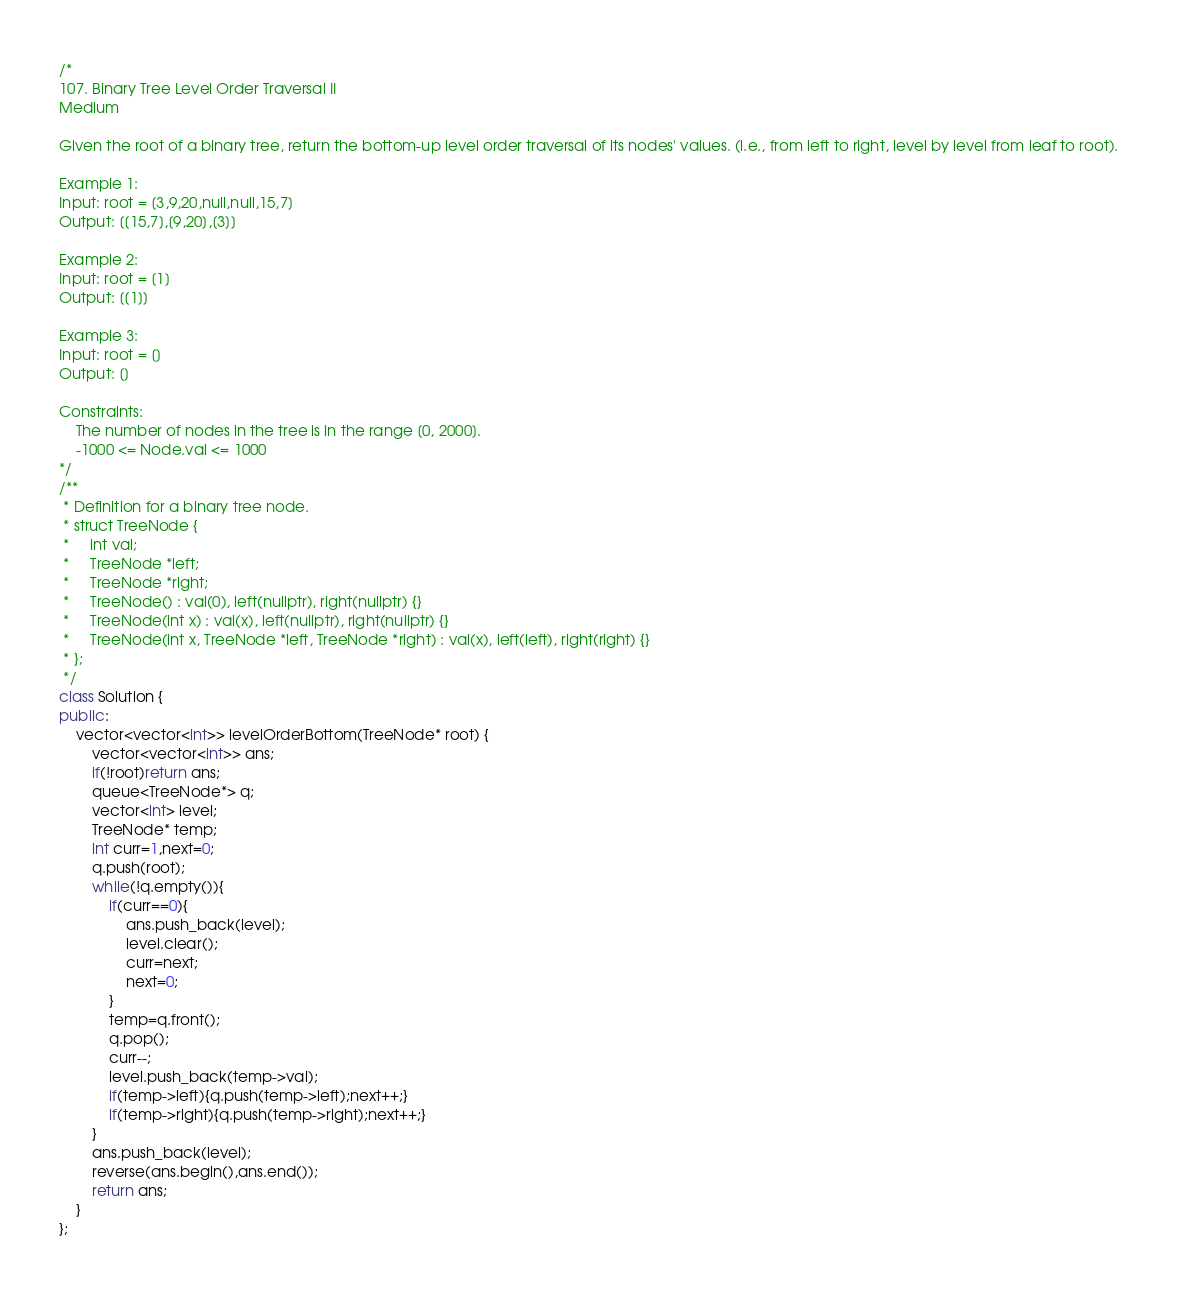Convert code to text. <code><loc_0><loc_0><loc_500><loc_500><_C++_>/*
107. Binary Tree Level Order Traversal II
Medium

Given the root of a binary tree, return the bottom-up level order traversal of its nodes' values. (i.e., from left to right, level by level from leaf to root).

Example 1:
Input: root = [3,9,20,null,null,15,7]
Output: [[15,7],[9,20],[3]]

Example 2:
Input: root = [1]
Output: [[1]]

Example 3:
Input: root = []
Output: []

Constraints:
    The number of nodes in the tree is in the range [0, 2000].
    -1000 <= Node.val <= 1000
*/
/**
 * Definition for a binary tree node.
 * struct TreeNode {
 *     int val;
 *     TreeNode *left;
 *     TreeNode *right;
 *     TreeNode() : val(0), left(nullptr), right(nullptr) {}
 *     TreeNode(int x) : val(x), left(nullptr), right(nullptr) {}
 *     TreeNode(int x, TreeNode *left, TreeNode *right) : val(x), left(left), right(right) {}
 * };
 */
class Solution {
public:
    vector<vector<int>> levelOrderBottom(TreeNode* root) {
        vector<vector<int>> ans;
        if(!root)return ans;
        queue<TreeNode*> q; 
        vector<int> level;
        TreeNode* temp;
        int curr=1,next=0;
        q.push(root);
        while(!q.empty()){
            if(curr==0){
                ans.push_back(level);
                level.clear();
                curr=next;
                next=0;
            }
            temp=q.front();
            q.pop();
            curr--;
            level.push_back(temp->val);
            if(temp->left){q.push(temp->left);next++;}
            if(temp->right){q.push(temp->right);next++;}
        }
        ans.push_back(level);
        reverse(ans.begin(),ans.end());
        return ans;
    }
};
</code> 